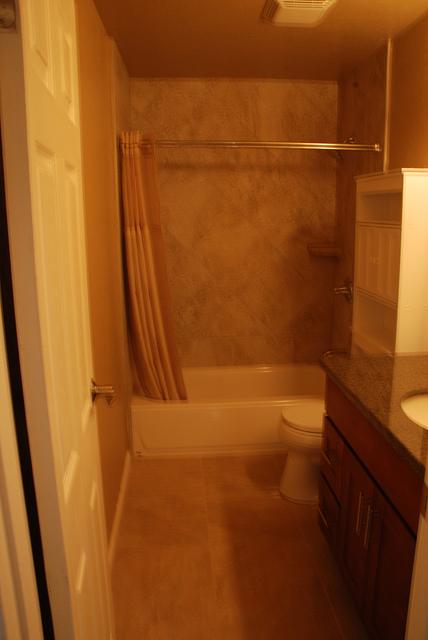What room is this?
Be succinct. Bathroom. Is this floor soft?
Write a very short answer. No. Does room appear clean?
Quick response, please. Yes. 